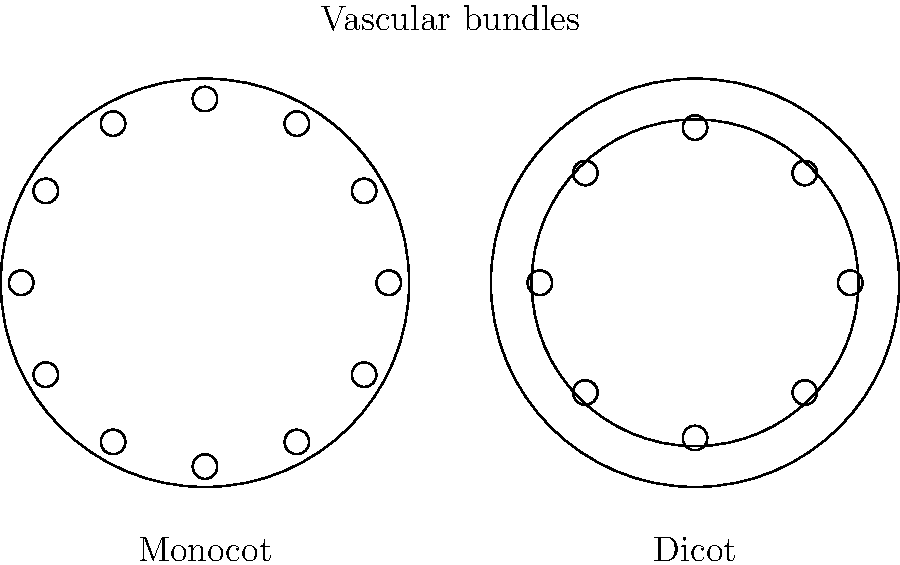As a teaching assistant leading a botany field trip, you come across two different plant stems. Upon examining their cross-sections under a microscope, you observe the patterns shown in the diagram. Which key anatomical feature distinguishes the monocot stem from the dicot stem, and how does this difference relate to their vascular bundle arrangement? To answer this question, let's analyze the cross-sectional anatomy of both stems step-by-step:

1. Monocot stem (left):
   - Vascular bundles are scattered throughout the stem.
   - No distinct ring pattern is visible.
   - Bundles appear smaller and more numerous.

2. Dicot stem (right):
   - Vascular bundles are arranged in a ring-like pattern.
   - A clear, circular arrangement of vascular tissue is visible.
   - Bundles appear larger and fewer in number.

3. Key distinguishing feature:
   - The arrangement of vascular bundles is the primary difference between monocot and dicot stems.

4. Relationship to vascular bundle arrangement:
   - Monocots: Vascular bundles are scattered randomly throughout the ground tissue, allowing for even distribution of water and nutrients.
   - Dicots: Vascular bundles form a ring, with the potential for secondary growth (thickness increase) between the inner and outer portions of the ring.

5. Functional implications:
   - Monocot arrangement supports flexible growth and is typical in plants like grasses and lilies.
   - Dicot arrangement allows for secondary growth, supporting woody tissue development in many trees and shrubs.

This anatomical difference is a fundamental characteristic used to classify flowering plants into monocotyledons and dicotyledons.
Answer: Vascular bundle arrangement: scattered in monocots, ring-shaped in dicots. 